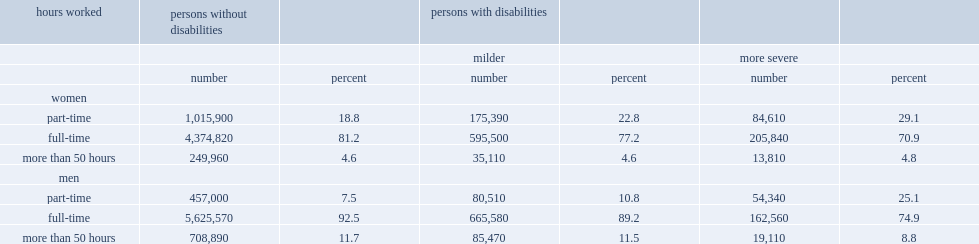Among those who were employed, which type of disability is were associated with a greater likelihood of working part-time? More severe. Among those aged 25 to 64 years, how many times of men with more severe disabilities were more likely to have been working part-time than men without disabilities? 3.346667. How many times of women with more severe disabilities were more likely than women without disabilities to have been part-time workers? 1.547872. 